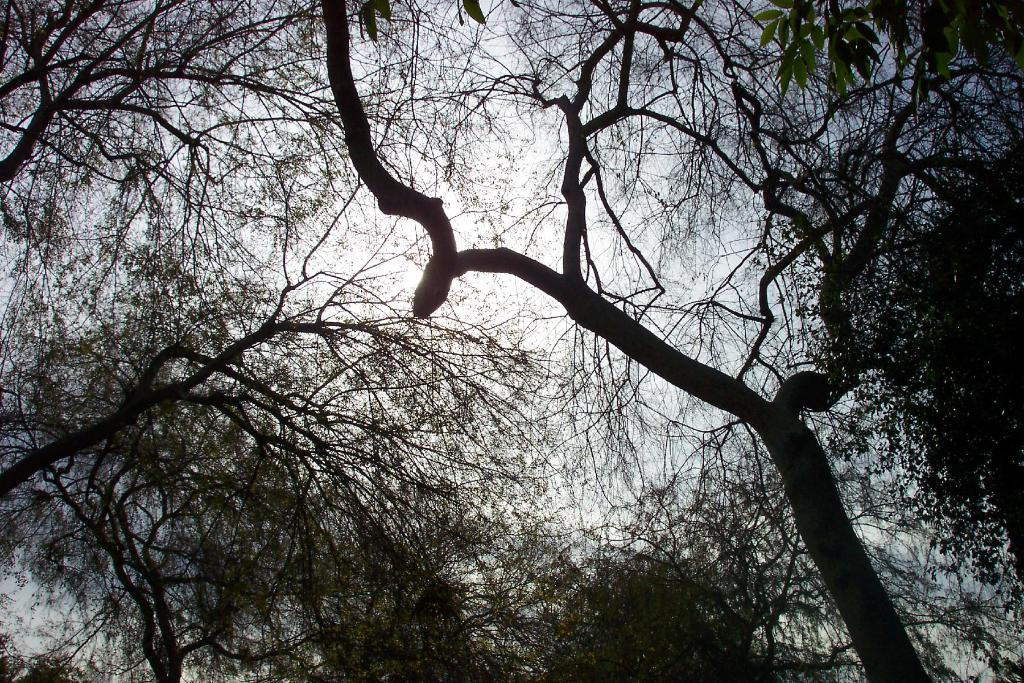What type of vegetation can be seen in the image? There are trees in the image. What colors are the trees in the image? The trees are green and black in color. What is visible in the background of the image? The sky is visible in the background of the image. Can the sun be seen in the image? Yes, the sun is observable in the sky. What type of airport can be seen near the coast in the image? There is no airport or coast present in the image; it features trees and a sky with the sun. 